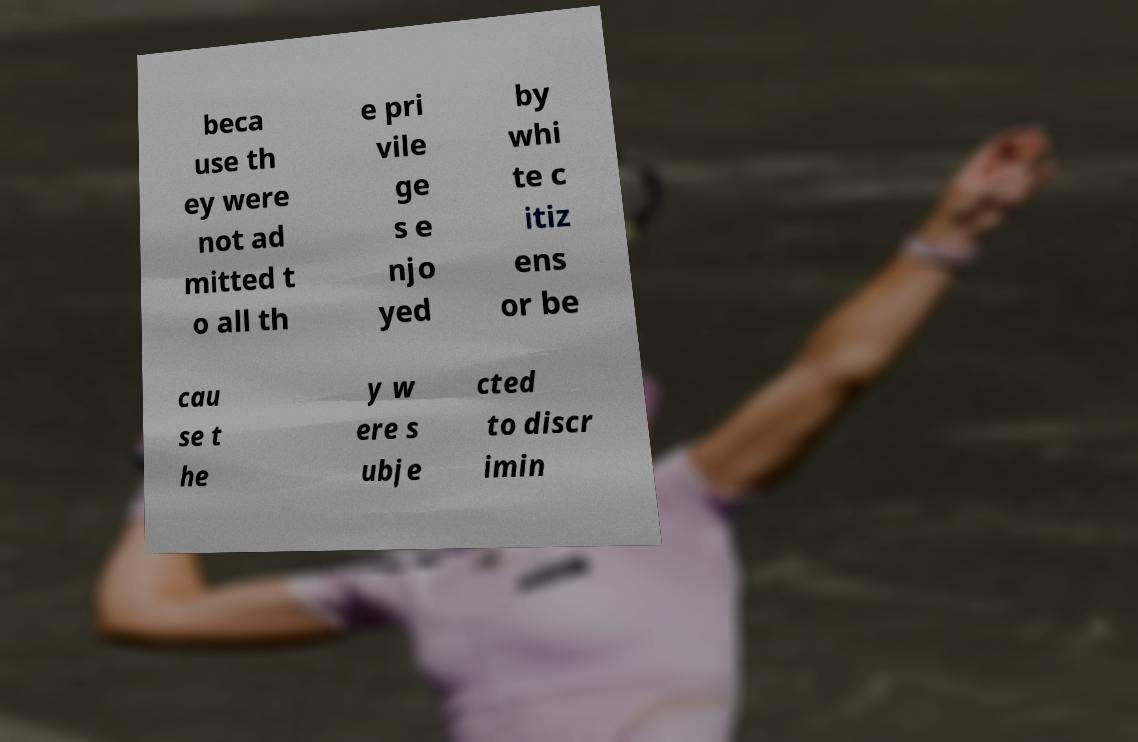Can you read and provide the text displayed in the image?This photo seems to have some interesting text. Can you extract and type it out for me? beca use th ey were not ad mitted t o all th e pri vile ge s e njo yed by whi te c itiz ens or be cau se t he y w ere s ubje cted to discr imin 